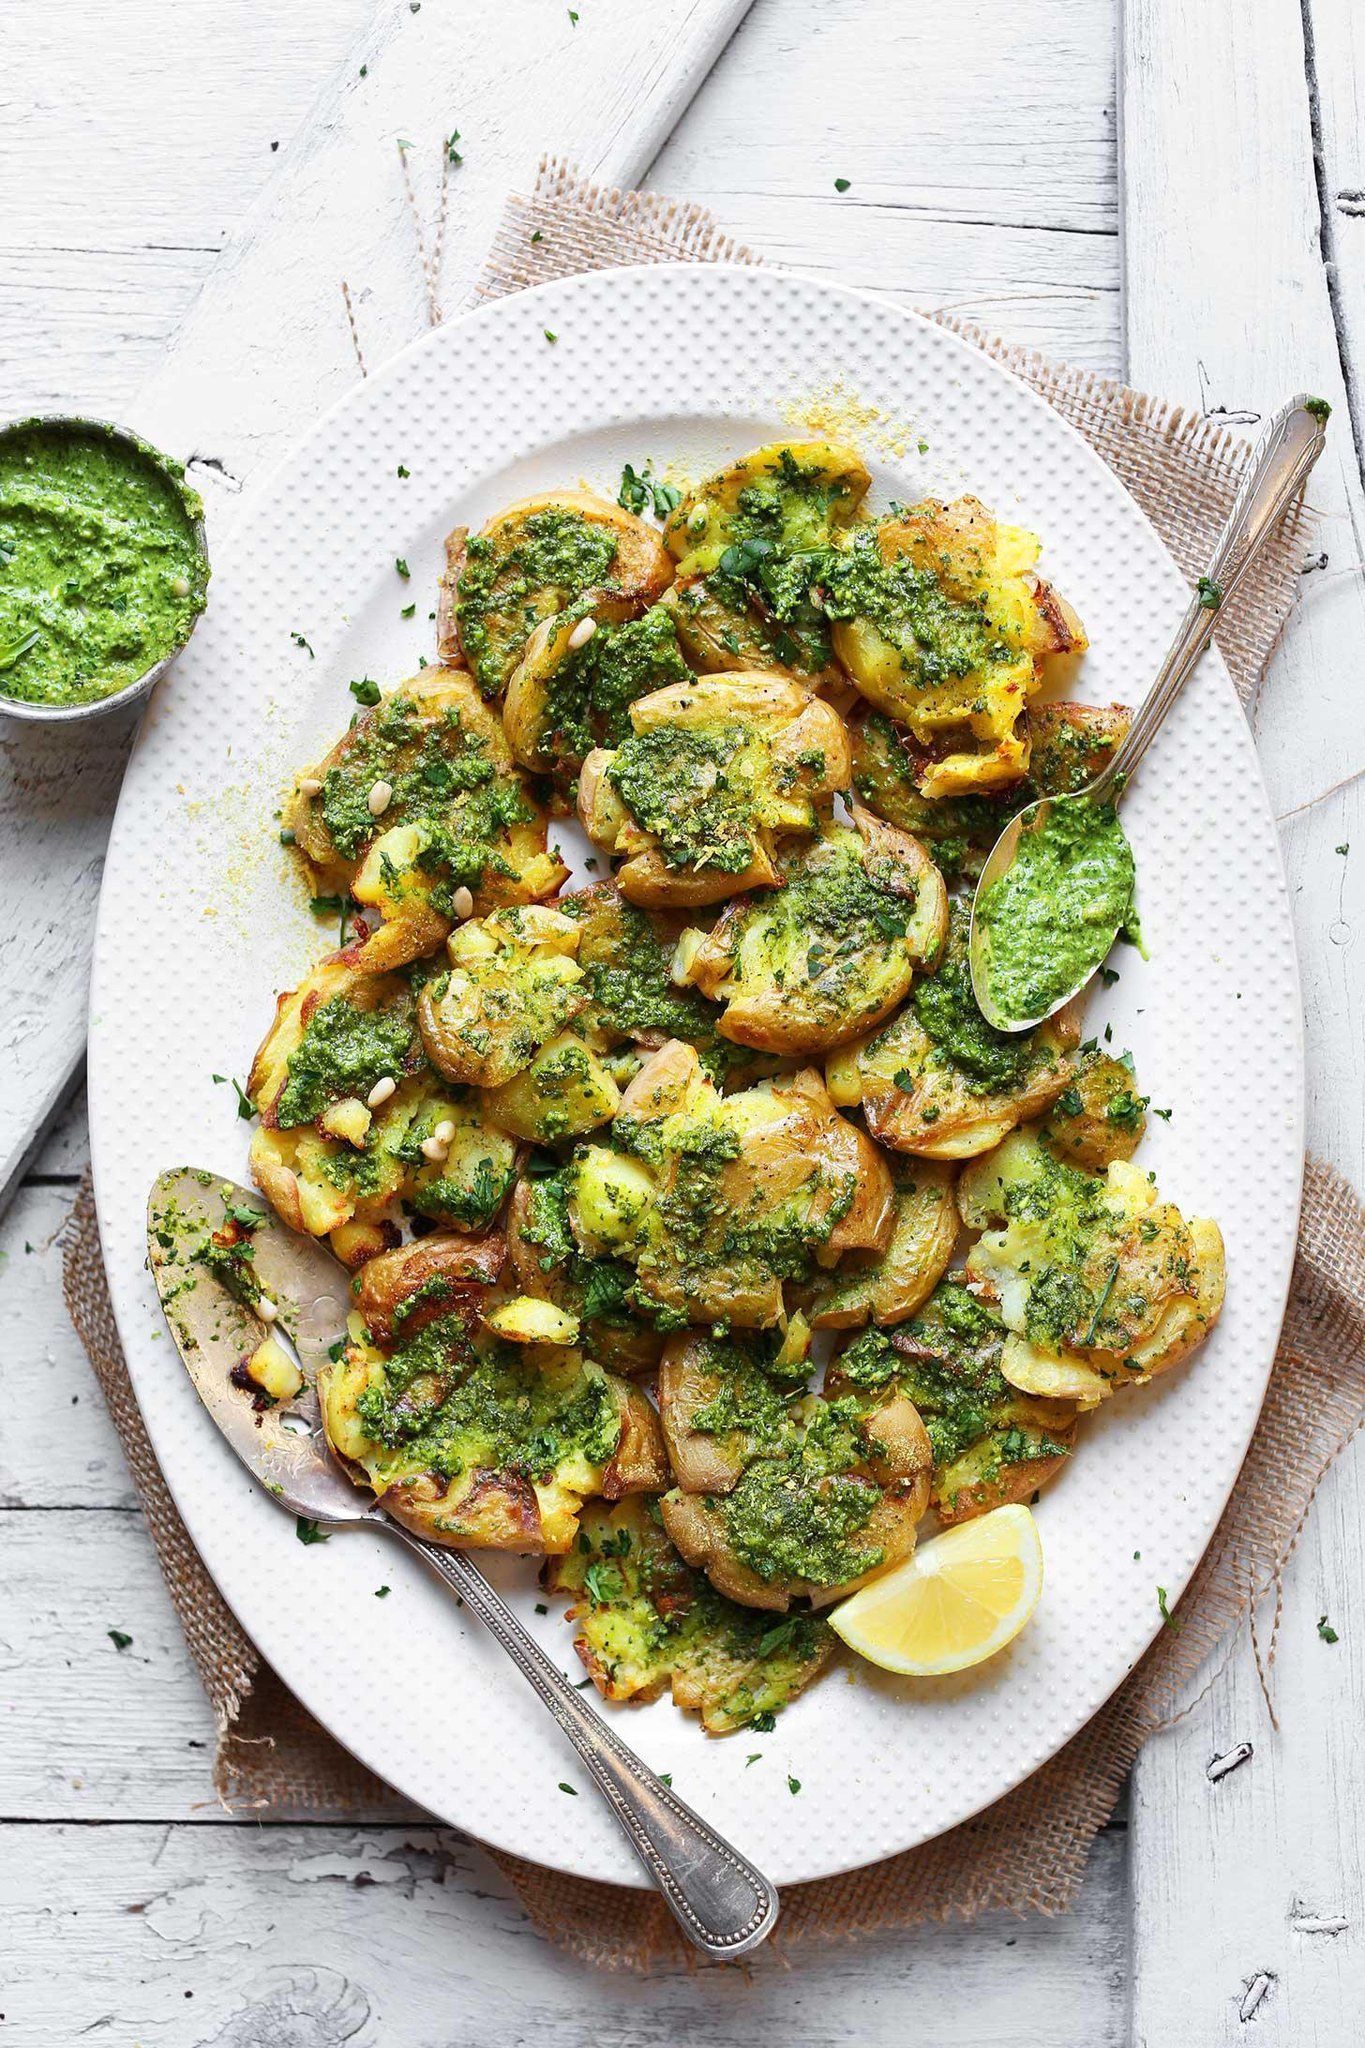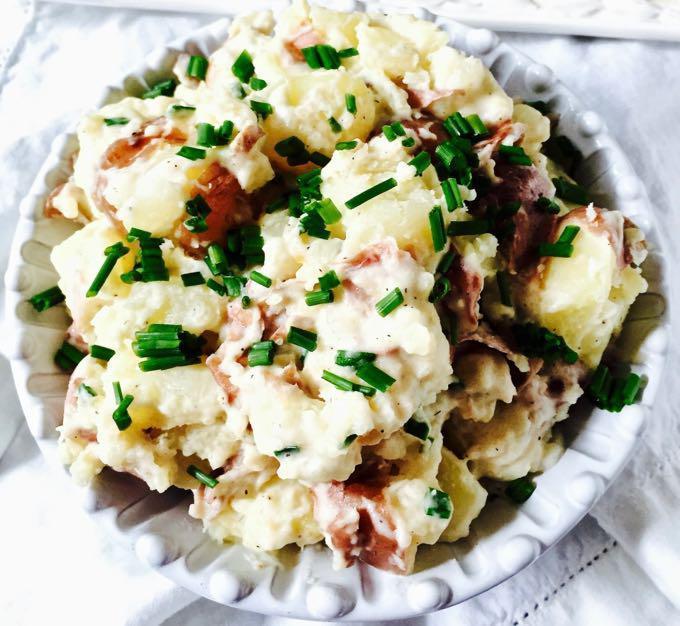The first image is the image on the left, the second image is the image on the right. Considering the images on both sides, is "In one of the images, there is a piece of silverware on table next to the food dish, and no silverware in the food itself." valid? Answer yes or no. No. 